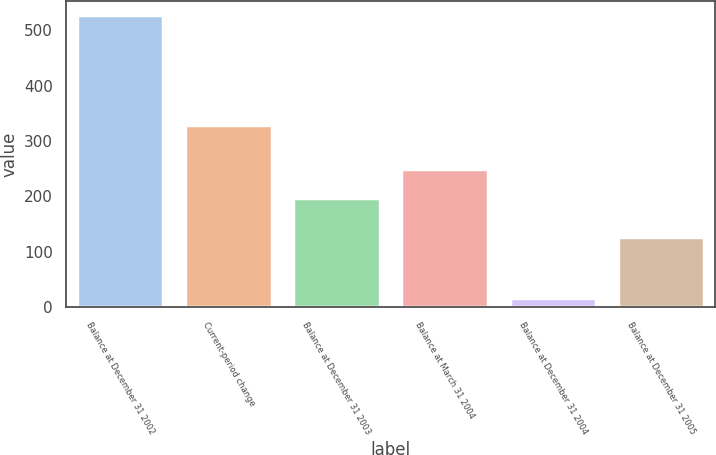<chart> <loc_0><loc_0><loc_500><loc_500><bar_chart><fcel>Balance at December 31 2002<fcel>Current-period change<fcel>Balance at December 31 2003<fcel>Balance at March 31 2004<fcel>Balance at December 31 2004<fcel>Balance at December 31 2005<nl><fcel>527<fcel>329<fcel>198<fcel>249<fcel>17<fcel>126<nl></chart> 